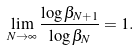Convert formula to latex. <formula><loc_0><loc_0><loc_500><loc_500>\lim _ { N \rightarrow \infty } \frac { \log \beta _ { N + 1 } } { \log \beta _ { N } } = 1 .</formula> 